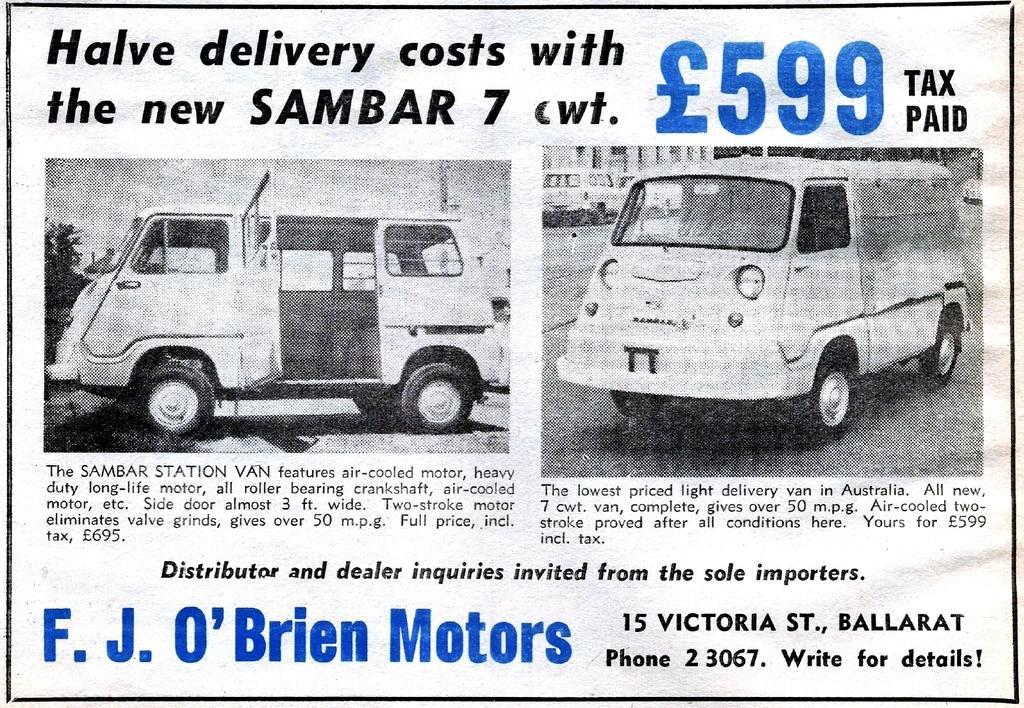Could you give a brief overview of what you see in this image? In this image we can see pictures of vehicles and texts written on the paper. 